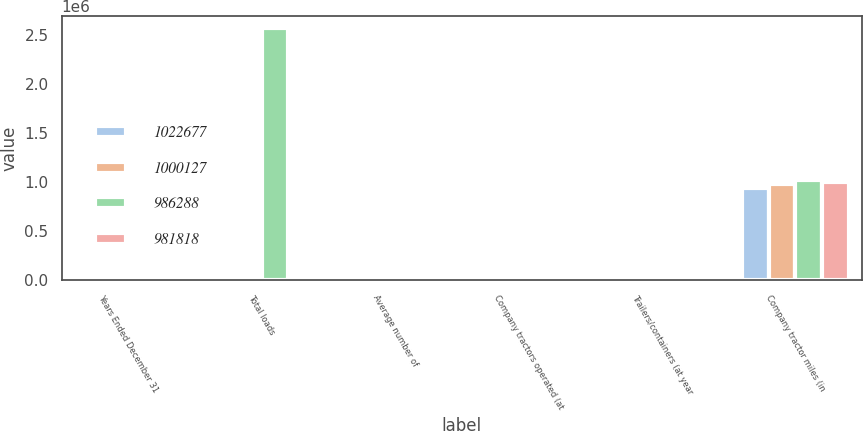Convert chart to OTSL. <chart><loc_0><loc_0><loc_500><loc_500><stacked_bar_chart><ecel><fcel>Years Ended December 31<fcel>Total loads<fcel>Average number of<fcel>Company tractors operated (at<fcel>Trailers/containers (at year<fcel>Company tractor miles (in<nl><fcel>1.02268e+06<fcel>2003<fcel>10712<fcel>10293<fcel>9932<fcel>46747<fcel>943054<nl><fcel>1.00013e+06<fcel>2002<fcel>10712<fcel>10712<fcel>10653<fcel>45759<fcel>981818<nl><fcel>986288<fcel>2001<fcel>2.56592e+06<fcel>10710<fcel>10770<fcel>44318<fcel>1.02268e+06<nl><fcel>981818<fcel>2000<fcel>10712<fcel>10055<fcel>10649<fcel>44330<fcel>1.00013e+06<nl></chart> 